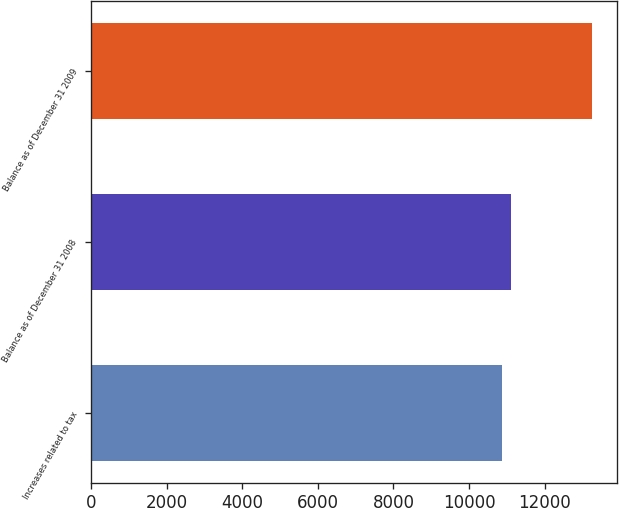Convert chart to OTSL. <chart><loc_0><loc_0><loc_500><loc_500><bar_chart><fcel>Increases related to tax<fcel>Balance as of December 31 2008<fcel>Balance as of December 31 2009<nl><fcel>10859<fcel>11097.5<fcel>13244<nl></chart> 